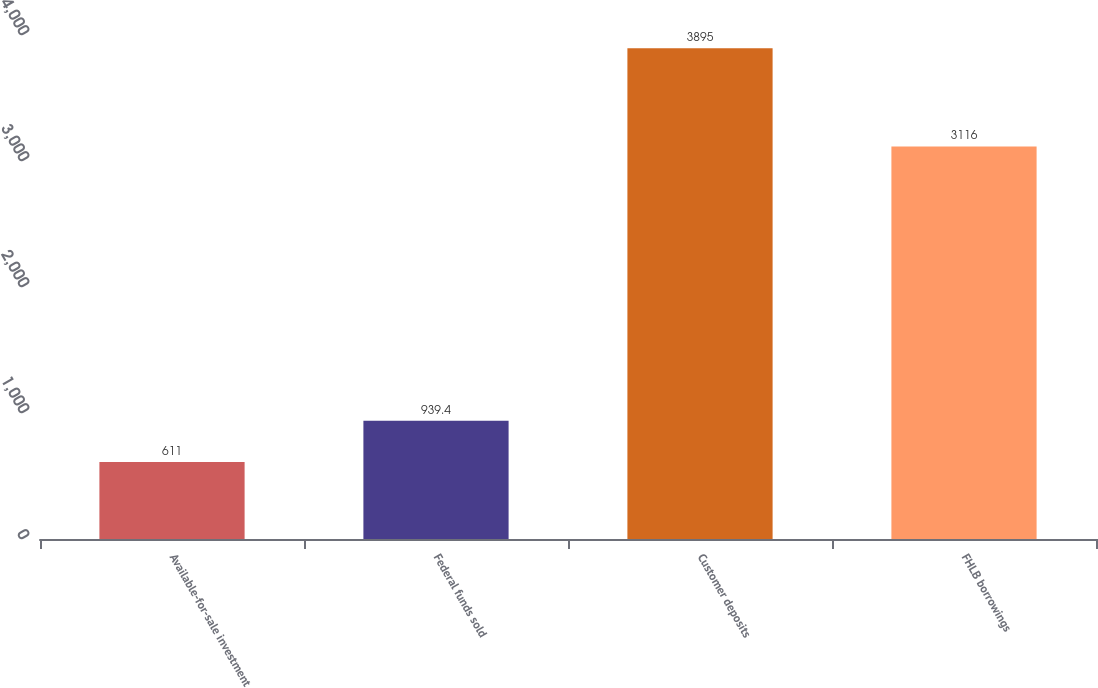Convert chart to OTSL. <chart><loc_0><loc_0><loc_500><loc_500><bar_chart><fcel>Available-for-sale investment<fcel>Federal funds sold<fcel>Customer deposits<fcel>FHLB borrowings<nl><fcel>611<fcel>939.4<fcel>3895<fcel>3116<nl></chart> 